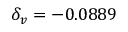<formula> <loc_0><loc_0><loc_500><loc_500>\delta _ { v } = - 0 . 0 8 8 9</formula> 